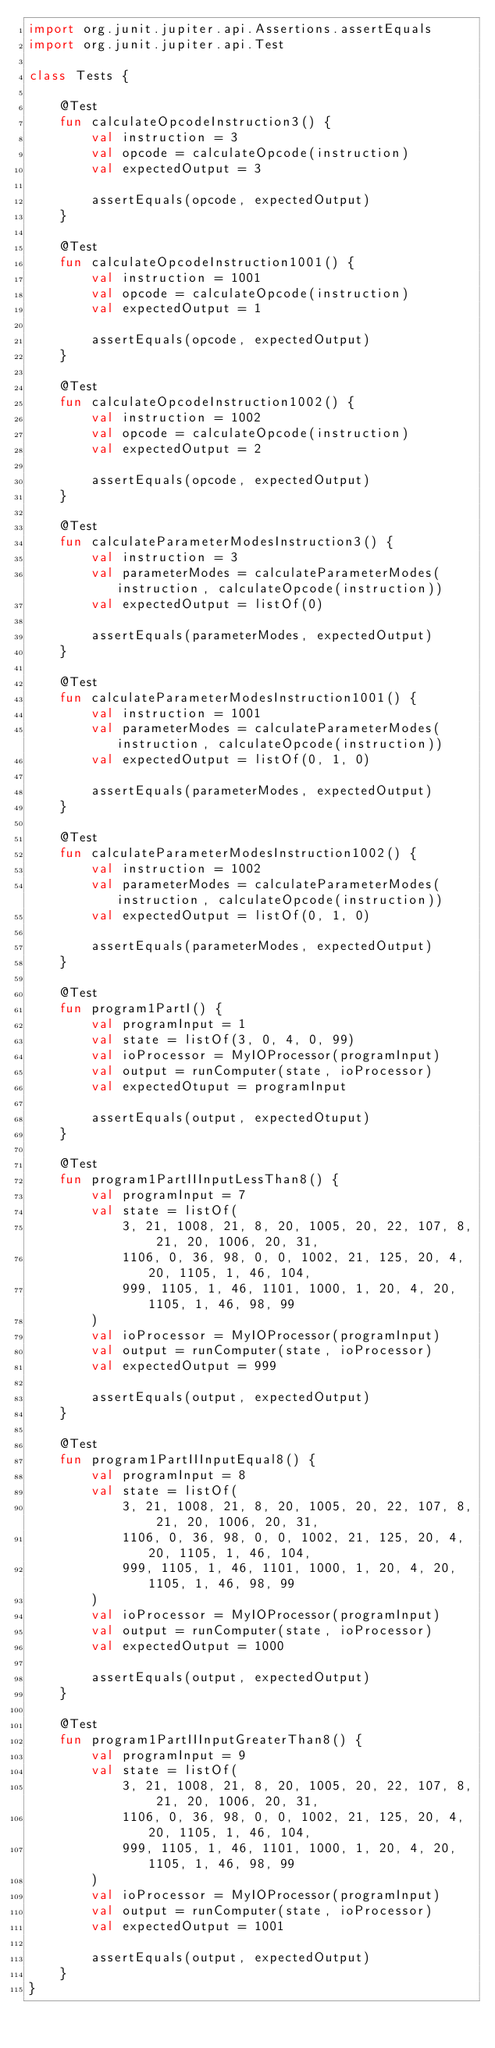<code> <loc_0><loc_0><loc_500><loc_500><_Kotlin_>import org.junit.jupiter.api.Assertions.assertEquals
import org.junit.jupiter.api.Test

class Tests {

    @Test
    fun calculateOpcodeInstruction3() {
        val instruction = 3
        val opcode = calculateOpcode(instruction)
        val expectedOutput = 3

        assertEquals(opcode, expectedOutput)
    }

    @Test
    fun calculateOpcodeInstruction1001() {
        val instruction = 1001
        val opcode = calculateOpcode(instruction)
        val expectedOutput = 1

        assertEquals(opcode, expectedOutput)
    }

    @Test
    fun calculateOpcodeInstruction1002() {
        val instruction = 1002
        val opcode = calculateOpcode(instruction)
        val expectedOutput = 2

        assertEquals(opcode, expectedOutput)
    }

    @Test
    fun calculateParameterModesInstruction3() {
        val instruction = 3
        val parameterModes = calculateParameterModes(instruction, calculateOpcode(instruction))
        val expectedOutput = listOf(0)

        assertEquals(parameterModes, expectedOutput)
    }

    @Test
    fun calculateParameterModesInstruction1001() {
        val instruction = 1001
        val parameterModes = calculateParameterModes(instruction, calculateOpcode(instruction))
        val expectedOutput = listOf(0, 1, 0)

        assertEquals(parameterModes, expectedOutput)
    }

    @Test
    fun calculateParameterModesInstruction1002() {
        val instruction = 1002
        val parameterModes = calculateParameterModes(instruction, calculateOpcode(instruction))
        val expectedOutput = listOf(0, 1, 0)

        assertEquals(parameterModes, expectedOutput)
    }

    @Test
    fun program1PartI() {
        val programInput = 1
        val state = listOf(3, 0, 4, 0, 99)
        val ioProcessor = MyIOProcessor(programInput)
        val output = runComputer(state, ioProcessor)
        val expectedOtuput = programInput

        assertEquals(output, expectedOtuput)
    }

    @Test
    fun program1PartIIInputLessThan8() {
        val programInput = 7
        val state = listOf(
            3, 21, 1008, 21, 8, 20, 1005, 20, 22, 107, 8, 21, 20, 1006, 20, 31,
            1106, 0, 36, 98, 0, 0, 1002, 21, 125, 20, 4, 20, 1105, 1, 46, 104,
            999, 1105, 1, 46, 1101, 1000, 1, 20, 4, 20, 1105, 1, 46, 98, 99
        )
        val ioProcessor = MyIOProcessor(programInput)
        val output = runComputer(state, ioProcessor)
        val expectedOutput = 999

        assertEquals(output, expectedOutput)
    }

    @Test
    fun program1PartIIInputEqual8() {
        val programInput = 8
        val state = listOf(
            3, 21, 1008, 21, 8, 20, 1005, 20, 22, 107, 8, 21, 20, 1006, 20, 31,
            1106, 0, 36, 98, 0, 0, 1002, 21, 125, 20, 4, 20, 1105, 1, 46, 104,
            999, 1105, 1, 46, 1101, 1000, 1, 20, 4, 20, 1105, 1, 46, 98, 99
        )
        val ioProcessor = MyIOProcessor(programInput)
        val output = runComputer(state, ioProcessor)
        val expectedOutput = 1000

        assertEquals(output, expectedOutput)
    }

    @Test
    fun program1PartIIInputGreaterThan8() {
        val programInput = 9
        val state = listOf(
            3, 21, 1008, 21, 8, 20, 1005, 20, 22, 107, 8, 21, 20, 1006, 20, 31,
            1106, 0, 36, 98, 0, 0, 1002, 21, 125, 20, 4, 20, 1105, 1, 46, 104,
            999, 1105, 1, 46, 1101, 1000, 1, 20, 4, 20, 1105, 1, 46, 98, 99
        )
        val ioProcessor = MyIOProcessor(programInput)
        val output = runComputer(state, ioProcessor)
        val expectedOutput = 1001

        assertEquals(output, expectedOutput)
    }
}
</code> 